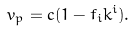<formula> <loc_0><loc_0><loc_500><loc_500>v _ { p } = c ( 1 - f _ { i } k ^ { i } ) .</formula> 